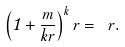<formula> <loc_0><loc_0><loc_500><loc_500>\left ( { 1 + \frac { m } { k r } } \right ) ^ { k } r = \ r .</formula> 